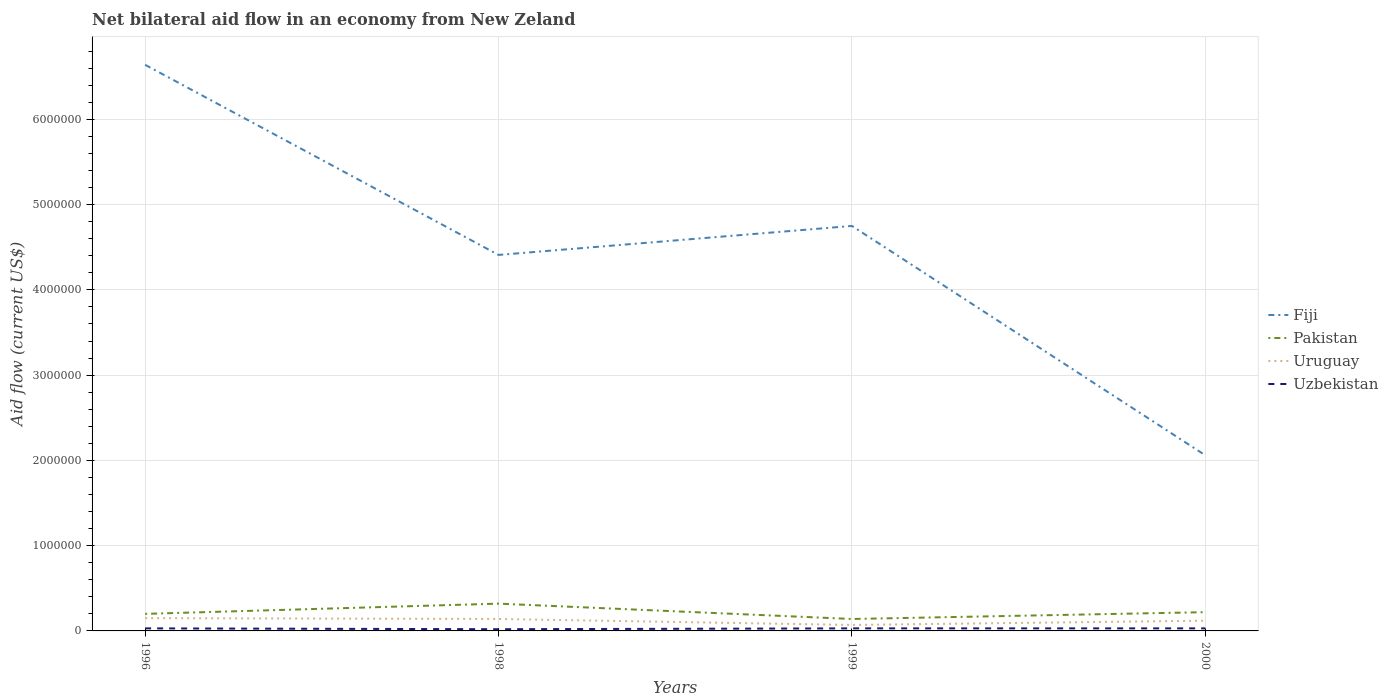Across all years, what is the maximum net bilateral aid flow in Uruguay?
Provide a short and direct response. 7.00e+04. What is the difference between the highest and the second highest net bilateral aid flow in Fiji?
Your response must be concise. 4.58e+06. What is the difference between two consecutive major ticks on the Y-axis?
Provide a short and direct response. 1.00e+06. Are the values on the major ticks of Y-axis written in scientific E-notation?
Provide a short and direct response. No. What is the title of the graph?
Provide a succinct answer. Net bilateral aid flow in an economy from New Zeland. Does "Ecuador" appear as one of the legend labels in the graph?
Offer a terse response. No. What is the Aid flow (current US$) in Fiji in 1996?
Offer a terse response. 6.64e+06. What is the Aid flow (current US$) of Uzbekistan in 1996?
Offer a very short reply. 3.00e+04. What is the Aid flow (current US$) in Fiji in 1998?
Keep it short and to the point. 4.41e+06. What is the Aid flow (current US$) of Pakistan in 1998?
Ensure brevity in your answer.  3.20e+05. What is the Aid flow (current US$) of Uruguay in 1998?
Your response must be concise. 1.40e+05. What is the Aid flow (current US$) in Uzbekistan in 1998?
Your answer should be compact. 2.00e+04. What is the Aid flow (current US$) of Fiji in 1999?
Offer a terse response. 4.75e+06. What is the Aid flow (current US$) in Pakistan in 1999?
Offer a very short reply. 1.40e+05. What is the Aid flow (current US$) of Fiji in 2000?
Provide a short and direct response. 2.06e+06. What is the Aid flow (current US$) in Uruguay in 2000?
Offer a very short reply. 1.20e+05. What is the Aid flow (current US$) of Uzbekistan in 2000?
Offer a terse response. 3.00e+04. Across all years, what is the maximum Aid flow (current US$) in Fiji?
Make the answer very short. 6.64e+06. Across all years, what is the maximum Aid flow (current US$) in Uruguay?
Keep it short and to the point. 1.50e+05. Across all years, what is the minimum Aid flow (current US$) of Fiji?
Provide a short and direct response. 2.06e+06. What is the total Aid flow (current US$) of Fiji in the graph?
Offer a terse response. 1.79e+07. What is the total Aid flow (current US$) in Pakistan in the graph?
Provide a short and direct response. 8.80e+05. What is the difference between the Aid flow (current US$) of Fiji in 1996 and that in 1998?
Keep it short and to the point. 2.23e+06. What is the difference between the Aid flow (current US$) in Uruguay in 1996 and that in 1998?
Provide a short and direct response. 10000. What is the difference between the Aid flow (current US$) in Uzbekistan in 1996 and that in 1998?
Offer a terse response. 10000. What is the difference between the Aid flow (current US$) in Fiji in 1996 and that in 1999?
Keep it short and to the point. 1.89e+06. What is the difference between the Aid flow (current US$) in Pakistan in 1996 and that in 1999?
Provide a short and direct response. 6.00e+04. What is the difference between the Aid flow (current US$) in Fiji in 1996 and that in 2000?
Offer a terse response. 4.58e+06. What is the difference between the Aid flow (current US$) in Pakistan in 1996 and that in 2000?
Ensure brevity in your answer.  -2.00e+04. What is the difference between the Aid flow (current US$) of Fiji in 1998 and that in 2000?
Make the answer very short. 2.35e+06. What is the difference between the Aid flow (current US$) of Pakistan in 1998 and that in 2000?
Provide a short and direct response. 1.00e+05. What is the difference between the Aid flow (current US$) of Uruguay in 1998 and that in 2000?
Ensure brevity in your answer.  2.00e+04. What is the difference between the Aid flow (current US$) in Fiji in 1999 and that in 2000?
Your answer should be compact. 2.69e+06. What is the difference between the Aid flow (current US$) in Pakistan in 1999 and that in 2000?
Give a very brief answer. -8.00e+04. What is the difference between the Aid flow (current US$) in Fiji in 1996 and the Aid flow (current US$) in Pakistan in 1998?
Ensure brevity in your answer.  6.32e+06. What is the difference between the Aid flow (current US$) of Fiji in 1996 and the Aid flow (current US$) of Uruguay in 1998?
Provide a succinct answer. 6.50e+06. What is the difference between the Aid flow (current US$) in Fiji in 1996 and the Aid flow (current US$) in Uzbekistan in 1998?
Ensure brevity in your answer.  6.62e+06. What is the difference between the Aid flow (current US$) in Pakistan in 1996 and the Aid flow (current US$) in Uruguay in 1998?
Keep it short and to the point. 6.00e+04. What is the difference between the Aid flow (current US$) in Pakistan in 1996 and the Aid flow (current US$) in Uzbekistan in 1998?
Keep it short and to the point. 1.80e+05. What is the difference between the Aid flow (current US$) of Uruguay in 1996 and the Aid flow (current US$) of Uzbekistan in 1998?
Offer a very short reply. 1.30e+05. What is the difference between the Aid flow (current US$) in Fiji in 1996 and the Aid flow (current US$) in Pakistan in 1999?
Your response must be concise. 6.50e+06. What is the difference between the Aid flow (current US$) of Fiji in 1996 and the Aid flow (current US$) of Uruguay in 1999?
Make the answer very short. 6.57e+06. What is the difference between the Aid flow (current US$) of Fiji in 1996 and the Aid flow (current US$) of Uzbekistan in 1999?
Make the answer very short. 6.61e+06. What is the difference between the Aid flow (current US$) of Uruguay in 1996 and the Aid flow (current US$) of Uzbekistan in 1999?
Your response must be concise. 1.20e+05. What is the difference between the Aid flow (current US$) in Fiji in 1996 and the Aid flow (current US$) in Pakistan in 2000?
Give a very brief answer. 6.42e+06. What is the difference between the Aid flow (current US$) of Fiji in 1996 and the Aid flow (current US$) of Uruguay in 2000?
Make the answer very short. 6.52e+06. What is the difference between the Aid flow (current US$) in Fiji in 1996 and the Aid flow (current US$) in Uzbekistan in 2000?
Ensure brevity in your answer.  6.61e+06. What is the difference between the Aid flow (current US$) in Uruguay in 1996 and the Aid flow (current US$) in Uzbekistan in 2000?
Your response must be concise. 1.20e+05. What is the difference between the Aid flow (current US$) in Fiji in 1998 and the Aid flow (current US$) in Pakistan in 1999?
Provide a short and direct response. 4.27e+06. What is the difference between the Aid flow (current US$) of Fiji in 1998 and the Aid flow (current US$) of Uruguay in 1999?
Provide a short and direct response. 4.34e+06. What is the difference between the Aid flow (current US$) of Fiji in 1998 and the Aid flow (current US$) of Uzbekistan in 1999?
Keep it short and to the point. 4.38e+06. What is the difference between the Aid flow (current US$) of Pakistan in 1998 and the Aid flow (current US$) of Uruguay in 1999?
Provide a short and direct response. 2.50e+05. What is the difference between the Aid flow (current US$) in Pakistan in 1998 and the Aid flow (current US$) in Uzbekistan in 1999?
Offer a terse response. 2.90e+05. What is the difference between the Aid flow (current US$) in Uruguay in 1998 and the Aid flow (current US$) in Uzbekistan in 1999?
Make the answer very short. 1.10e+05. What is the difference between the Aid flow (current US$) in Fiji in 1998 and the Aid flow (current US$) in Pakistan in 2000?
Provide a short and direct response. 4.19e+06. What is the difference between the Aid flow (current US$) of Fiji in 1998 and the Aid flow (current US$) of Uruguay in 2000?
Provide a short and direct response. 4.29e+06. What is the difference between the Aid flow (current US$) in Fiji in 1998 and the Aid flow (current US$) in Uzbekistan in 2000?
Make the answer very short. 4.38e+06. What is the difference between the Aid flow (current US$) in Pakistan in 1998 and the Aid flow (current US$) in Uzbekistan in 2000?
Provide a short and direct response. 2.90e+05. What is the difference between the Aid flow (current US$) of Fiji in 1999 and the Aid flow (current US$) of Pakistan in 2000?
Provide a succinct answer. 4.53e+06. What is the difference between the Aid flow (current US$) of Fiji in 1999 and the Aid flow (current US$) of Uruguay in 2000?
Make the answer very short. 4.63e+06. What is the difference between the Aid flow (current US$) in Fiji in 1999 and the Aid flow (current US$) in Uzbekistan in 2000?
Your answer should be very brief. 4.72e+06. What is the difference between the Aid flow (current US$) of Pakistan in 1999 and the Aid flow (current US$) of Uruguay in 2000?
Ensure brevity in your answer.  2.00e+04. What is the difference between the Aid flow (current US$) in Pakistan in 1999 and the Aid flow (current US$) in Uzbekistan in 2000?
Provide a succinct answer. 1.10e+05. What is the difference between the Aid flow (current US$) of Uruguay in 1999 and the Aid flow (current US$) of Uzbekistan in 2000?
Keep it short and to the point. 4.00e+04. What is the average Aid flow (current US$) of Fiji per year?
Keep it short and to the point. 4.46e+06. What is the average Aid flow (current US$) of Uruguay per year?
Give a very brief answer. 1.20e+05. What is the average Aid flow (current US$) in Uzbekistan per year?
Keep it short and to the point. 2.75e+04. In the year 1996, what is the difference between the Aid flow (current US$) in Fiji and Aid flow (current US$) in Pakistan?
Your response must be concise. 6.44e+06. In the year 1996, what is the difference between the Aid flow (current US$) of Fiji and Aid flow (current US$) of Uruguay?
Offer a terse response. 6.49e+06. In the year 1996, what is the difference between the Aid flow (current US$) of Fiji and Aid flow (current US$) of Uzbekistan?
Your answer should be compact. 6.61e+06. In the year 1996, what is the difference between the Aid flow (current US$) of Pakistan and Aid flow (current US$) of Uruguay?
Your response must be concise. 5.00e+04. In the year 1998, what is the difference between the Aid flow (current US$) in Fiji and Aid flow (current US$) in Pakistan?
Provide a short and direct response. 4.09e+06. In the year 1998, what is the difference between the Aid flow (current US$) of Fiji and Aid flow (current US$) of Uruguay?
Make the answer very short. 4.27e+06. In the year 1998, what is the difference between the Aid flow (current US$) in Fiji and Aid flow (current US$) in Uzbekistan?
Provide a short and direct response. 4.39e+06. In the year 1998, what is the difference between the Aid flow (current US$) in Pakistan and Aid flow (current US$) in Uruguay?
Your answer should be very brief. 1.80e+05. In the year 1998, what is the difference between the Aid flow (current US$) in Uruguay and Aid flow (current US$) in Uzbekistan?
Offer a terse response. 1.20e+05. In the year 1999, what is the difference between the Aid flow (current US$) of Fiji and Aid flow (current US$) of Pakistan?
Keep it short and to the point. 4.61e+06. In the year 1999, what is the difference between the Aid flow (current US$) in Fiji and Aid flow (current US$) in Uruguay?
Offer a terse response. 4.68e+06. In the year 1999, what is the difference between the Aid flow (current US$) in Fiji and Aid flow (current US$) in Uzbekistan?
Provide a succinct answer. 4.72e+06. In the year 1999, what is the difference between the Aid flow (current US$) in Pakistan and Aid flow (current US$) in Uzbekistan?
Your answer should be compact. 1.10e+05. In the year 1999, what is the difference between the Aid flow (current US$) of Uruguay and Aid flow (current US$) of Uzbekistan?
Ensure brevity in your answer.  4.00e+04. In the year 2000, what is the difference between the Aid flow (current US$) of Fiji and Aid flow (current US$) of Pakistan?
Offer a terse response. 1.84e+06. In the year 2000, what is the difference between the Aid flow (current US$) of Fiji and Aid flow (current US$) of Uruguay?
Provide a succinct answer. 1.94e+06. In the year 2000, what is the difference between the Aid flow (current US$) of Fiji and Aid flow (current US$) of Uzbekistan?
Ensure brevity in your answer.  2.03e+06. In the year 2000, what is the difference between the Aid flow (current US$) of Pakistan and Aid flow (current US$) of Uruguay?
Provide a succinct answer. 1.00e+05. In the year 2000, what is the difference between the Aid flow (current US$) in Uruguay and Aid flow (current US$) in Uzbekistan?
Your answer should be very brief. 9.00e+04. What is the ratio of the Aid flow (current US$) of Fiji in 1996 to that in 1998?
Provide a short and direct response. 1.51. What is the ratio of the Aid flow (current US$) in Pakistan in 1996 to that in 1998?
Your answer should be very brief. 0.62. What is the ratio of the Aid flow (current US$) in Uruguay in 1996 to that in 1998?
Provide a short and direct response. 1.07. What is the ratio of the Aid flow (current US$) in Fiji in 1996 to that in 1999?
Ensure brevity in your answer.  1.4. What is the ratio of the Aid flow (current US$) of Pakistan in 1996 to that in 1999?
Offer a terse response. 1.43. What is the ratio of the Aid flow (current US$) of Uruguay in 1996 to that in 1999?
Your response must be concise. 2.14. What is the ratio of the Aid flow (current US$) in Uzbekistan in 1996 to that in 1999?
Your answer should be very brief. 1. What is the ratio of the Aid flow (current US$) in Fiji in 1996 to that in 2000?
Provide a succinct answer. 3.22. What is the ratio of the Aid flow (current US$) of Uruguay in 1996 to that in 2000?
Your answer should be very brief. 1.25. What is the ratio of the Aid flow (current US$) of Fiji in 1998 to that in 1999?
Your answer should be compact. 0.93. What is the ratio of the Aid flow (current US$) of Pakistan in 1998 to that in 1999?
Offer a very short reply. 2.29. What is the ratio of the Aid flow (current US$) of Uruguay in 1998 to that in 1999?
Keep it short and to the point. 2. What is the ratio of the Aid flow (current US$) of Uzbekistan in 1998 to that in 1999?
Keep it short and to the point. 0.67. What is the ratio of the Aid flow (current US$) in Fiji in 1998 to that in 2000?
Your response must be concise. 2.14. What is the ratio of the Aid flow (current US$) in Pakistan in 1998 to that in 2000?
Offer a very short reply. 1.45. What is the ratio of the Aid flow (current US$) of Uruguay in 1998 to that in 2000?
Make the answer very short. 1.17. What is the ratio of the Aid flow (current US$) of Fiji in 1999 to that in 2000?
Your answer should be compact. 2.31. What is the ratio of the Aid flow (current US$) in Pakistan in 1999 to that in 2000?
Your answer should be compact. 0.64. What is the ratio of the Aid flow (current US$) in Uruguay in 1999 to that in 2000?
Keep it short and to the point. 0.58. What is the difference between the highest and the second highest Aid flow (current US$) of Fiji?
Make the answer very short. 1.89e+06. What is the difference between the highest and the second highest Aid flow (current US$) in Pakistan?
Ensure brevity in your answer.  1.00e+05. What is the difference between the highest and the lowest Aid flow (current US$) of Fiji?
Offer a terse response. 4.58e+06. 